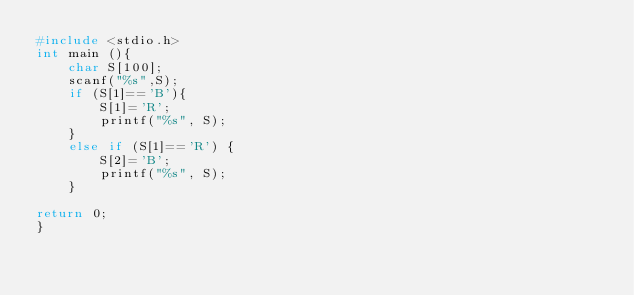<code> <loc_0><loc_0><loc_500><loc_500><_C_>#include <stdio.h>
int main (){
	char S[100];
	scanf("%s",S);
	if (S[1]=='B'){
		S[1]='R';
		printf("%s", S);
	}
	else if (S[1]=='R') {
		S[2]='B';
		printf("%s", S);
	}
	
return 0;
}</code> 